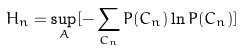<formula> <loc_0><loc_0><loc_500><loc_500>H _ { n } = \sup _ { A } [ - \sum _ { C _ { n } } P ( C _ { n } ) \ln P ( C _ { n } ) ]</formula> 